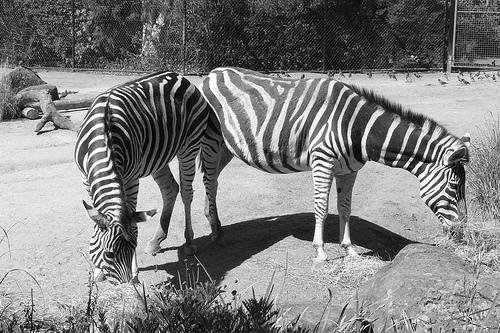Based on the length of the shadows, is it morning, mid-day, or evening?
Concise answer only. Mid-day. Are these zebras sitting?
Keep it brief. No. How many zebras are there?
Concise answer only. 2. 